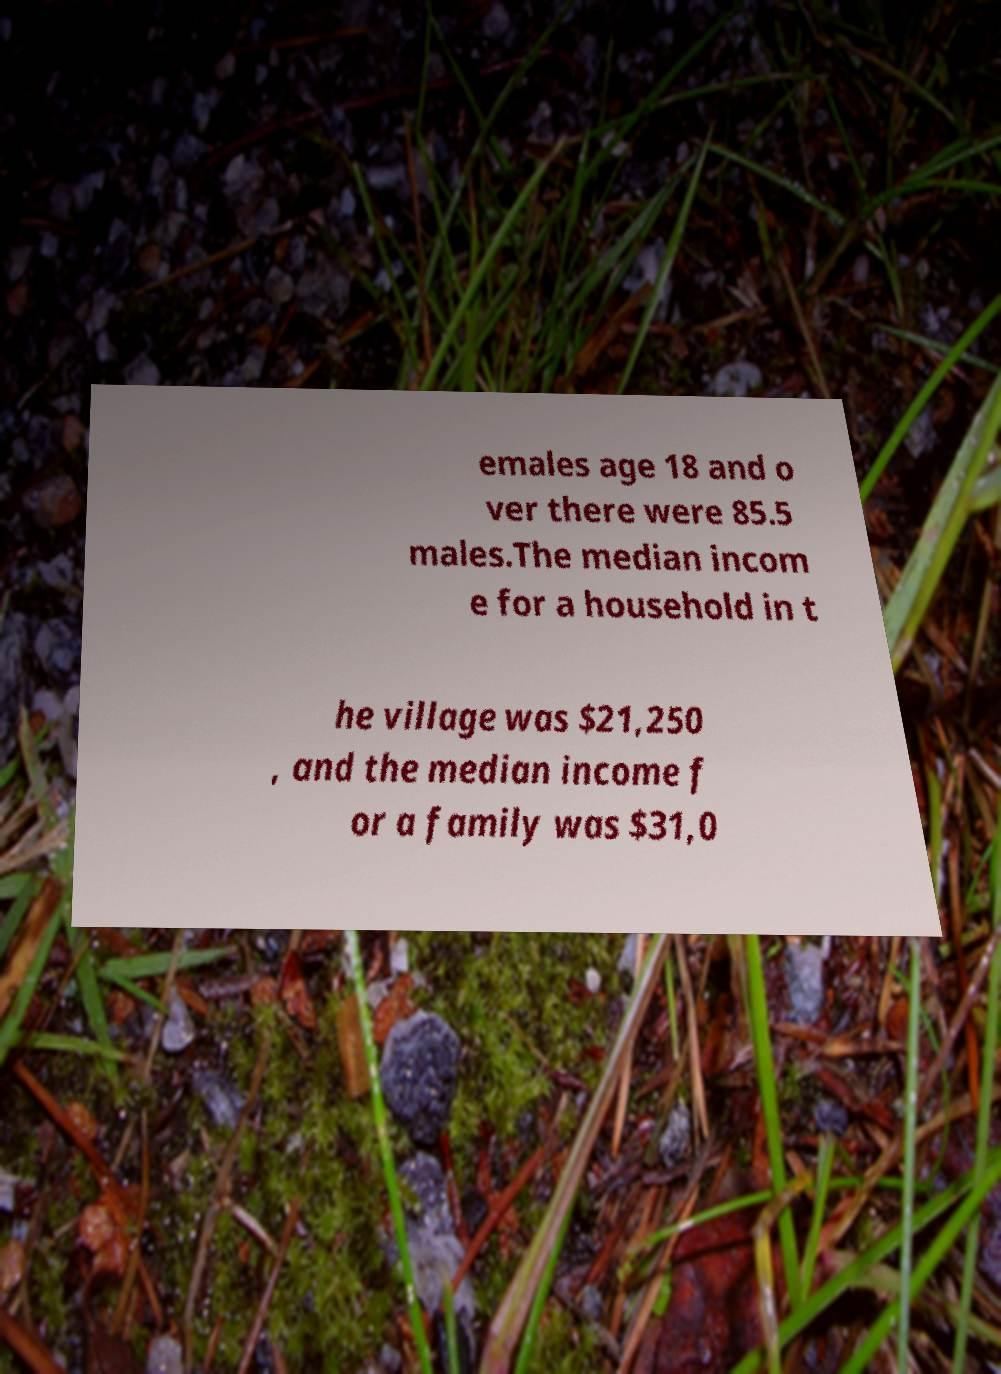There's text embedded in this image that I need extracted. Can you transcribe it verbatim? emales age 18 and o ver there were 85.5 males.The median incom e for a household in t he village was $21,250 , and the median income f or a family was $31,0 